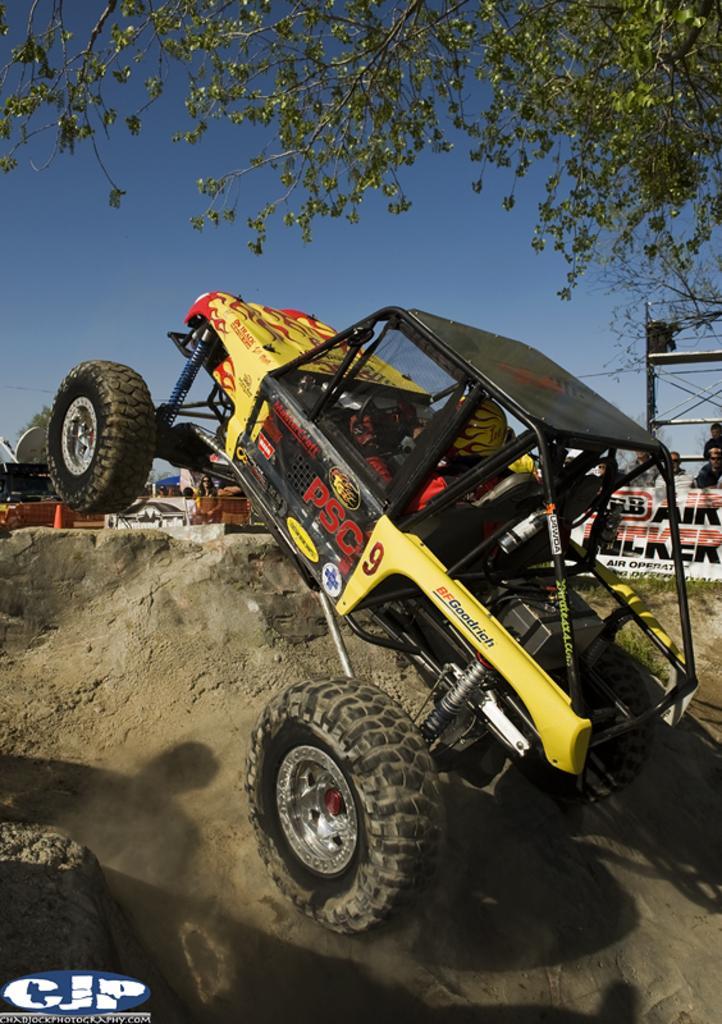In one or two sentences, can you explain what this image depicts? In this picture there is a jeep wrangler in the center of the image, on a muddy floor, there is a poster and a pole in the background area of the image and there is a tree at the top side of the image. 